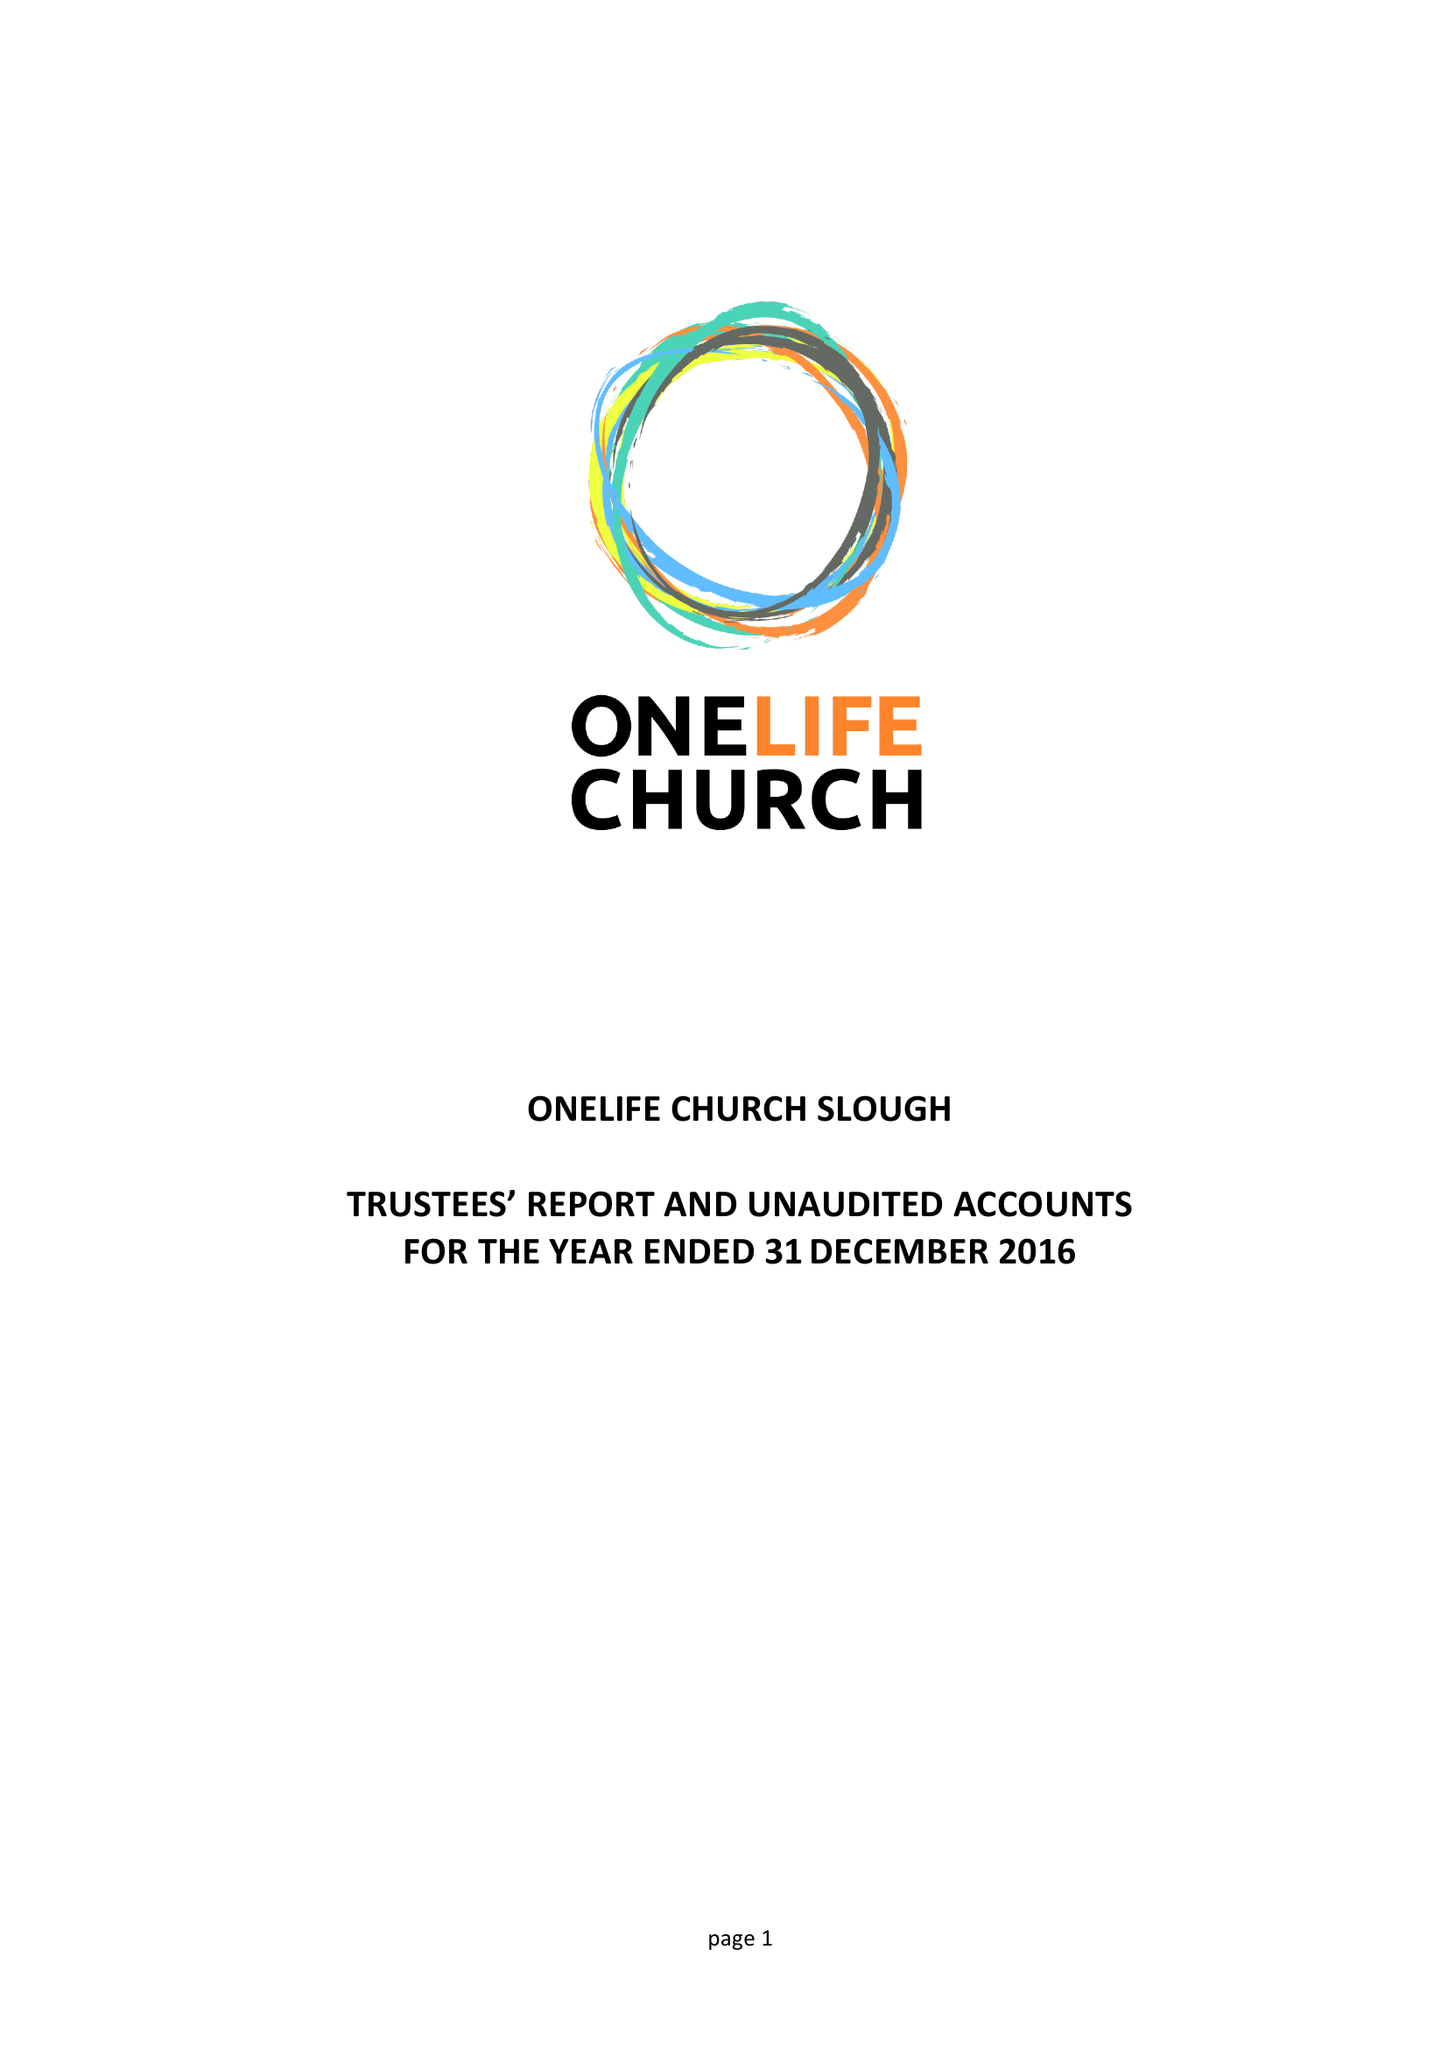What is the value for the charity_number?
Answer the question using a single word or phrase. 1156309 